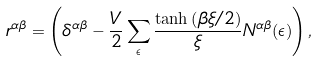Convert formula to latex. <formula><loc_0><loc_0><loc_500><loc_500>r ^ { \alpha \beta } = \left ( \delta ^ { \alpha \beta } - \frac { V } { 2 } \sum _ { \epsilon } \frac { \tanh \left ( \beta \xi / 2 \right ) } { \xi } N ^ { \alpha \beta } ( \epsilon ) \right ) ,</formula> 